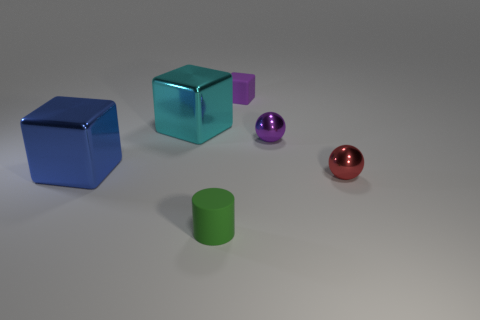Subtract all large cyan cubes. How many cubes are left? 2 Add 1 large red balls. How many objects exist? 7 Subtract all red spheres. How many spheres are left? 1 Subtract all cylinders. How many objects are left? 5 Add 5 purple balls. How many purple balls exist? 6 Subtract 0 purple cylinders. How many objects are left? 6 Subtract all purple cylinders. Subtract all blue cubes. How many cylinders are left? 1 Subtract all tiny green matte cylinders. Subtract all red things. How many objects are left? 4 Add 6 tiny purple balls. How many tiny purple balls are left? 7 